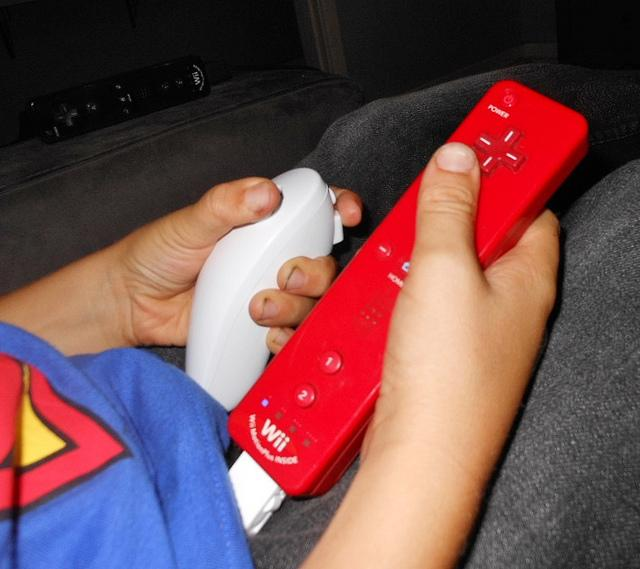How many players can play?

Choices:
A) three
B) one
C) four
D) two two 